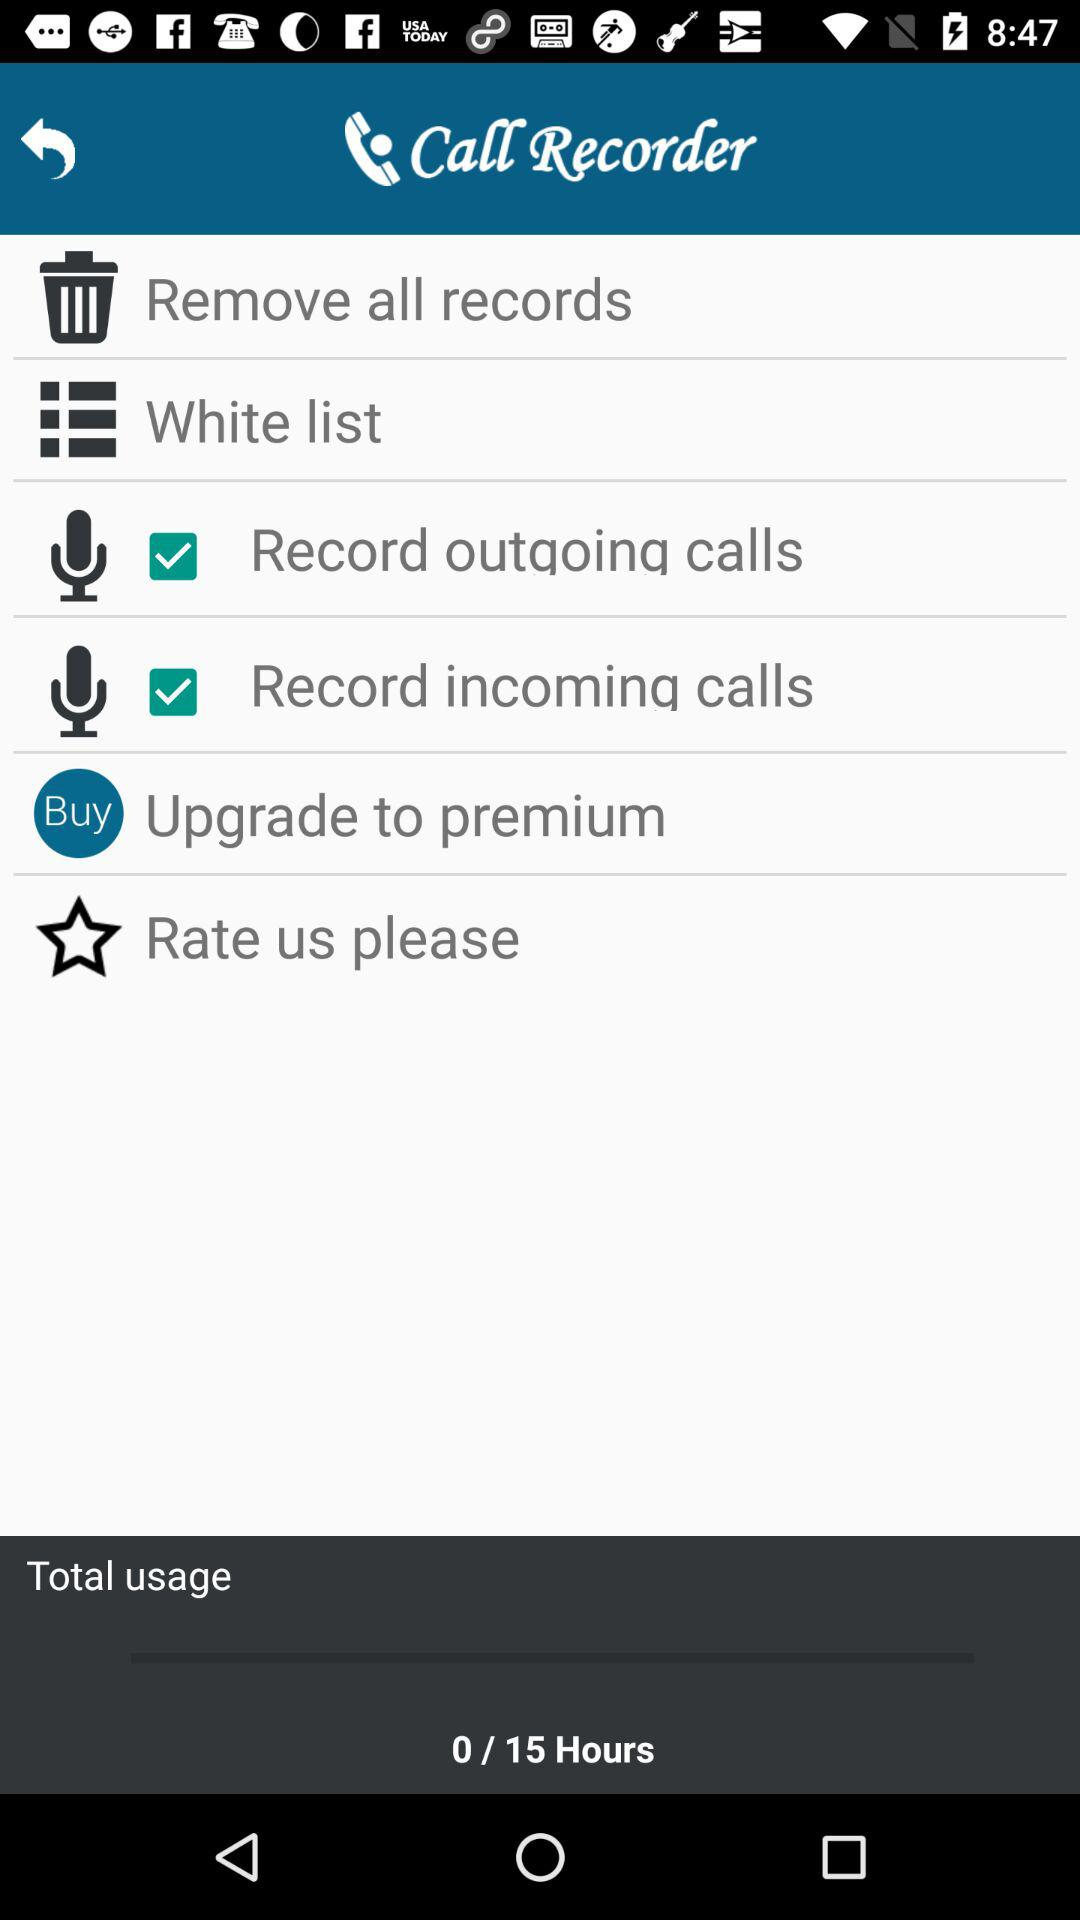What are the total usage hours? The total usage hours are 15. 